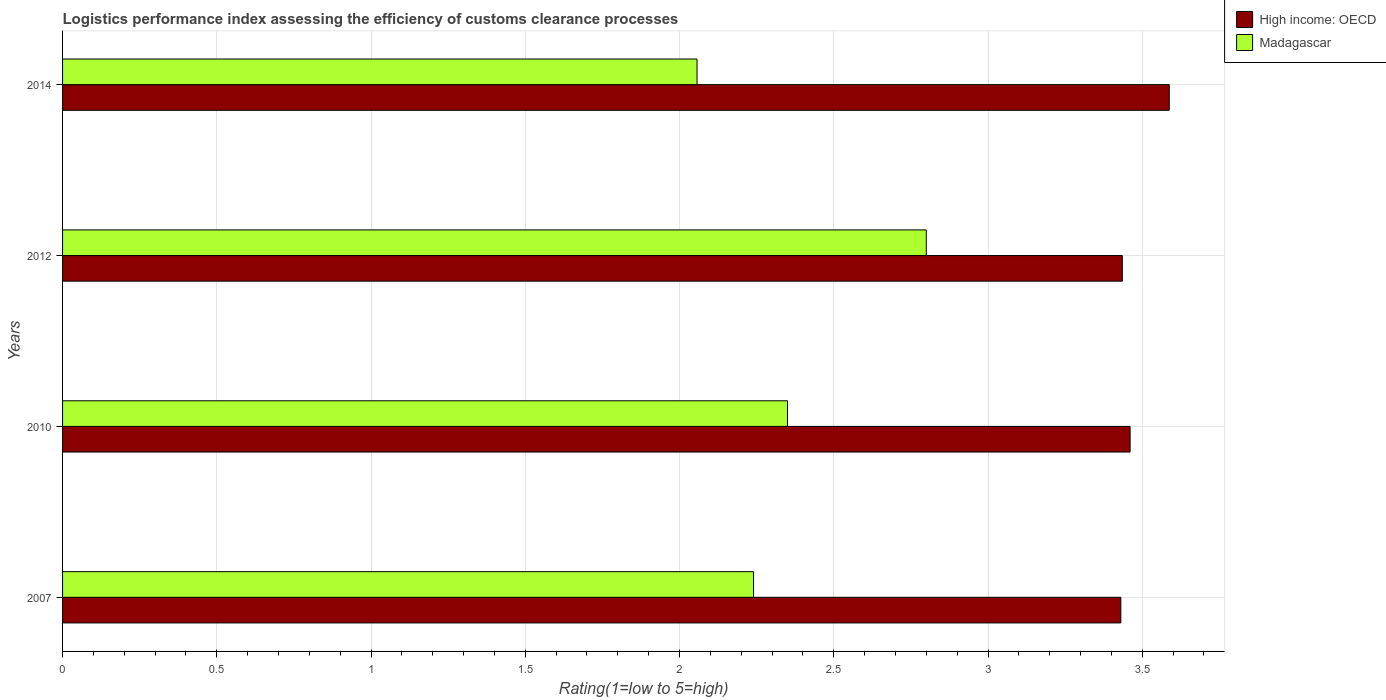What is the label of the 2nd group of bars from the top?
Offer a terse response. 2012. What is the Logistic performance index in Madagascar in 2007?
Your answer should be very brief. 2.24. Across all years, what is the maximum Logistic performance index in Madagascar?
Give a very brief answer. 2.8. Across all years, what is the minimum Logistic performance index in Madagascar?
Ensure brevity in your answer.  2.06. In which year was the Logistic performance index in Madagascar maximum?
Ensure brevity in your answer.  2012. In which year was the Logistic performance index in Madagascar minimum?
Your answer should be compact. 2014. What is the total Logistic performance index in Madagascar in the graph?
Your answer should be compact. 9.45. What is the difference between the Logistic performance index in High income: OECD in 2010 and that in 2014?
Offer a very short reply. -0.13. What is the difference between the Logistic performance index in Madagascar in 2010 and the Logistic performance index in High income: OECD in 2012?
Provide a short and direct response. -1.09. What is the average Logistic performance index in Madagascar per year?
Make the answer very short. 2.36. In the year 2014, what is the difference between the Logistic performance index in High income: OECD and Logistic performance index in Madagascar?
Provide a short and direct response. 1.53. In how many years, is the Logistic performance index in High income: OECD greater than 0.30000000000000004 ?
Your response must be concise. 4. What is the ratio of the Logistic performance index in Madagascar in 2007 to that in 2012?
Offer a terse response. 0.8. What is the difference between the highest and the second highest Logistic performance index in Madagascar?
Your response must be concise. 0.45. What is the difference between the highest and the lowest Logistic performance index in High income: OECD?
Your response must be concise. 0.16. What does the 1st bar from the top in 2012 represents?
Your answer should be compact. Madagascar. What does the 2nd bar from the bottom in 2012 represents?
Your response must be concise. Madagascar. How many years are there in the graph?
Provide a short and direct response. 4. What is the difference between two consecutive major ticks on the X-axis?
Offer a very short reply. 0.5. Are the values on the major ticks of X-axis written in scientific E-notation?
Your response must be concise. No. Where does the legend appear in the graph?
Offer a very short reply. Top right. How many legend labels are there?
Ensure brevity in your answer.  2. What is the title of the graph?
Your answer should be compact. Logistics performance index assessing the efficiency of customs clearance processes. Does "Azerbaijan" appear as one of the legend labels in the graph?
Give a very brief answer. No. What is the label or title of the X-axis?
Your answer should be compact. Rating(1=low to 5=high). What is the label or title of the Y-axis?
Offer a terse response. Years. What is the Rating(1=low to 5=high) of High income: OECD in 2007?
Offer a terse response. 3.43. What is the Rating(1=low to 5=high) of Madagascar in 2007?
Ensure brevity in your answer.  2.24. What is the Rating(1=low to 5=high) in High income: OECD in 2010?
Your response must be concise. 3.46. What is the Rating(1=low to 5=high) of Madagascar in 2010?
Keep it short and to the point. 2.35. What is the Rating(1=low to 5=high) in High income: OECD in 2012?
Your answer should be compact. 3.44. What is the Rating(1=low to 5=high) of High income: OECD in 2014?
Provide a succinct answer. 3.59. What is the Rating(1=low to 5=high) of Madagascar in 2014?
Make the answer very short. 2.06. Across all years, what is the maximum Rating(1=low to 5=high) in High income: OECD?
Keep it short and to the point. 3.59. Across all years, what is the maximum Rating(1=low to 5=high) in Madagascar?
Your answer should be compact. 2.8. Across all years, what is the minimum Rating(1=low to 5=high) in High income: OECD?
Keep it short and to the point. 3.43. Across all years, what is the minimum Rating(1=low to 5=high) in Madagascar?
Your answer should be compact. 2.06. What is the total Rating(1=low to 5=high) of High income: OECD in the graph?
Your answer should be compact. 13.91. What is the total Rating(1=low to 5=high) of Madagascar in the graph?
Your response must be concise. 9.45. What is the difference between the Rating(1=low to 5=high) in High income: OECD in 2007 and that in 2010?
Make the answer very short. -0.03. What is the difference between the Rating(1=low to 5=high) of Madagascar in 2007 and that in 2010?
Offer a terse response. -0.11. What is the difference between the Rating(1=low to 5=high) in High income: OECD in 2007 and that in 2012?
Your answer should be compact. -0. What is the difference between the Rating(1=low to 5=high) of Madagascar in 2007 and that in 2012?
Your answer should be compact. -0.56. What is the difference between the Rating(1=low to 5=high) in High income: OECD in 2007 and that in 2014?
Make the answer very short. -0.16. What is the difference between the Rating(1=low to 5=high) of Madagascar in 2007 and that in 2014?
Offer a terse response. 0.18. What is the difference between the Rating(1=low to 5=high) in High income: OECD in 2010 and that in 2012?
Offer a terse response. 0.03. What is the difference between the Rating(1=low to 5=high) of Madagascar in 2010 and that in 2012?
Your answer should be compact. -0.45. What is the difference between the Rating(1=low to 5=high) of High income: OECD in 2010 and that in 2014?
Keep it short and to the point. -0.13. What is the difference between the Rating(1=low to 5=high) in Madagascar in 2010 and that in 2014?
Keep it short and to the point. 0.29. What is the difference between the Rating(1=low to 5=high) of High income: OECD in 2012 and that in 2014?
Your answer should be very brief. -0.15. What is the difference between the Rating(1=low to 5=high) of Madagascar in 2012 and that in 2014?
Provide a succinct answer. 0.74. What is the difference between the Rating(1=low to 5=high) in High income: OECD in 2007 and the Rating(1=low to 5=high) in Madagascar in 2010?
Provide a succinct answer. 1.08. What is the difference between the Rating(1=low to 5=high) in High income: OECD in 2007 and the Rating(1=low to 5=high) in Madagascar in 2012?
Your response must be concise. 0.63. What is the difference between the Rating(1=low to 5=high) in High income: OECD in 2007 and the Rating(1=low to 5=high) in Madagascar in 2014?
Your response must be concise. 1.37. What is the difference between the Rating(1=low to 5=high) in High income: OECD in 2010 and the Rating(1=low to 5=high) in Madagascar in 2012?
Keep it short and to the point. 0.66. What is the difference between the Rating(1=low to 5=high) in High income: OECD in 2010 and the Rating(1=low to 5=high) in Madagascar in 2014?
Offer a very short reply. 1.4. What is the difference between the Rating(1=low to 5=high) of High income: OECD in 2012 and the Rating(1=low to 5=high) of Madagascar in 2014?
Keep it short and to the point. 1.38. What is the average Rating(1=low to 5=high) of High income: OECD per year?
Provide a succinct answer. 3.48. What is the average Rating(1=low to 5=high) in Madagascar per year?
Give a very brief answer. 2.36. In the year 2007, what is the difference between the Rating(1=low to 5=high) of High income: OECD and Rating(1=low to 5=high) of Madagascar?
Your answer should be very brief. 1.19. In the year 2010, what is the difference between the Rating(1=low to 5=high) in High income: OECD and Rating(1=low to 5=high) in Madagascar?
Your answer should be very brief. 1.11. In the year 2012, what is the difference between the Rating(1=low to 5=high) of High income: OECD and Rating(1=low to 5=high) of Madagascar?
Provide a succinct answer. 0.64. In the year 2014, what is the difference between the Rating(1=low to 5=high) in High income: OECD and Rating(1=low to 5=high) in Madagascar?
Ensure brevity in your answer.  1.53. What is the ratio of the Rating(1=low to 5=high) in Madagascar in 2007 to that in 2010?
Provide a short and direct response. 0.95. What is the ratio of the Rating(1=low to 5=high) in High income: OECD in 2007 to that in 2012?
Offer a very short reply. 1. What is the ratio of the Rating(1=low to 5=high) of Madagascar in 2007 to that in 2012?
Provide a succinct answer. 0.8. What is the ratio of the Rating(1=low to 5=high) in High income: OECD in 2007 to that in 2014?
Your answer should be compact. 0.96. What is the ratio of the Rating(1=low to 5=high) of Madagascar in 2007 to that in 2014?
Make the answer very short. 1.09. What is the ratio of the Rating(1=low to 5=high) of High income: OECD in 2010 to that in 2012?
Provide a succinct answer. 1.01. What is the ratio of the Rating(1=low to 5=high) in Madagascar in 2010 to that in 2012?
Your answer should be very brief. 0.84. What is the ratio of the Rating(1=low to 5=high) of High income: OECD in 2010 to that in 2014?
Ensure brevity in your answer.  0.96. What is the ratio of the Rating(1=low to 5=high) of Madagascar in 2010 to that in 2014?
Keep it short and to the point. 1.14. What is the ratio of the Rating(1=low to 5=high) of High income: OECD in 2012 to that in 2014?
Provide a short and direct response. 0.96. What is the ratio of the Rating(1=low to 5=high) of Madagascar in 2012 to that in 2014?
Make the answer very short. 1.36. What is the difference between the highest and the second highest Rating(1=low to 5=high) in High income: OECD?
Keep it short and to the point. 0.13. What is the difference between the highest and the second highest Rating(1=low to 5=high) in Madagascar?
Offer a very short reply. 0.45. What is the difference between the highest and the lowest Rating(1=low to 5=high) of High income: OECD?
Your answer should be compact. 0.16. What is the difference between the highest and the lowest Rating(1=low to 5=high) of Madagascar?
Give a very brief answer. 0.74. 